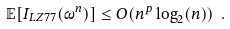Convert formula to latex. <formula><loc_0><loc_0><loc_500><loc_500>\mathbb { E } [ I _ { L Z 7 7 } ( \omega ^ { n } ) ] \leq O ( n ^ { p } \log _ { 2 } ( n ) ) \ .</formula> 